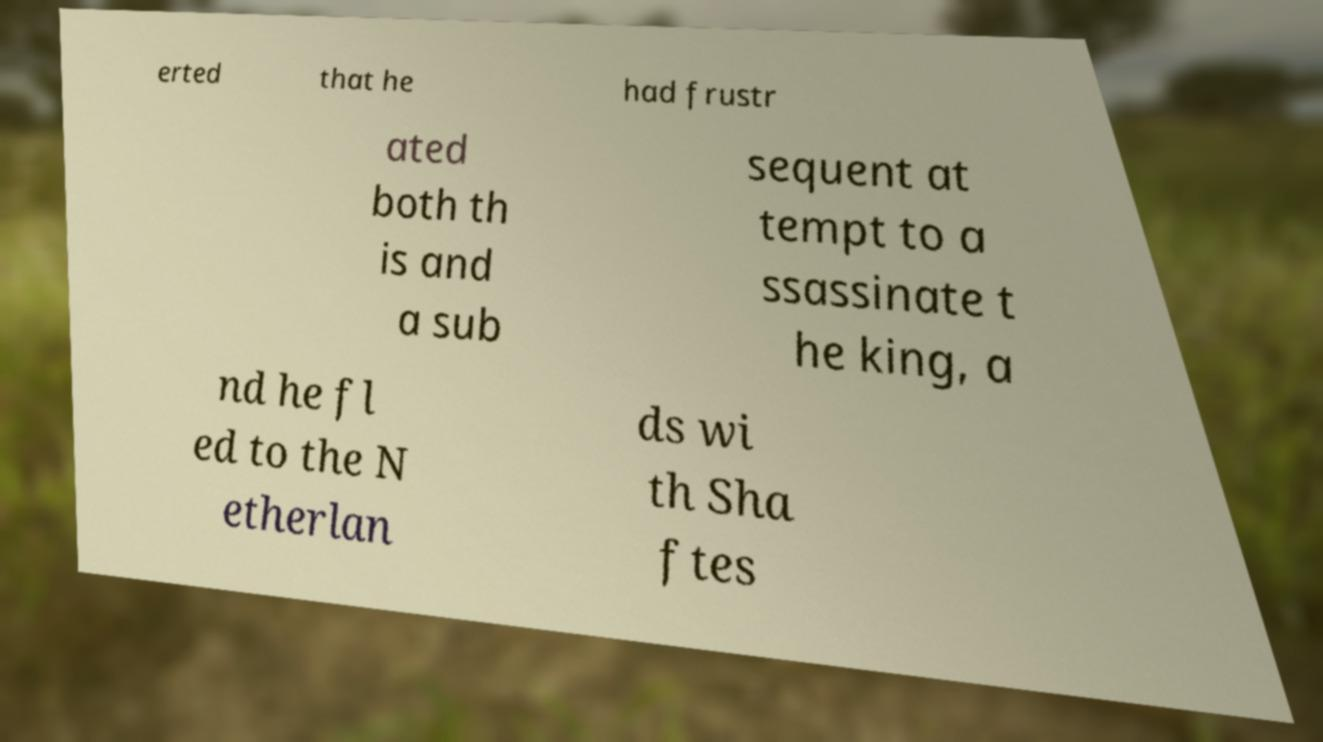Please read and relay the text visible in this image. What does it say? erted that he had frustr ated both th is and a sub sequent at tempt to a ssassinate t he king, a nd he fl ed to the N etherlan ds wi th Sha ftes 